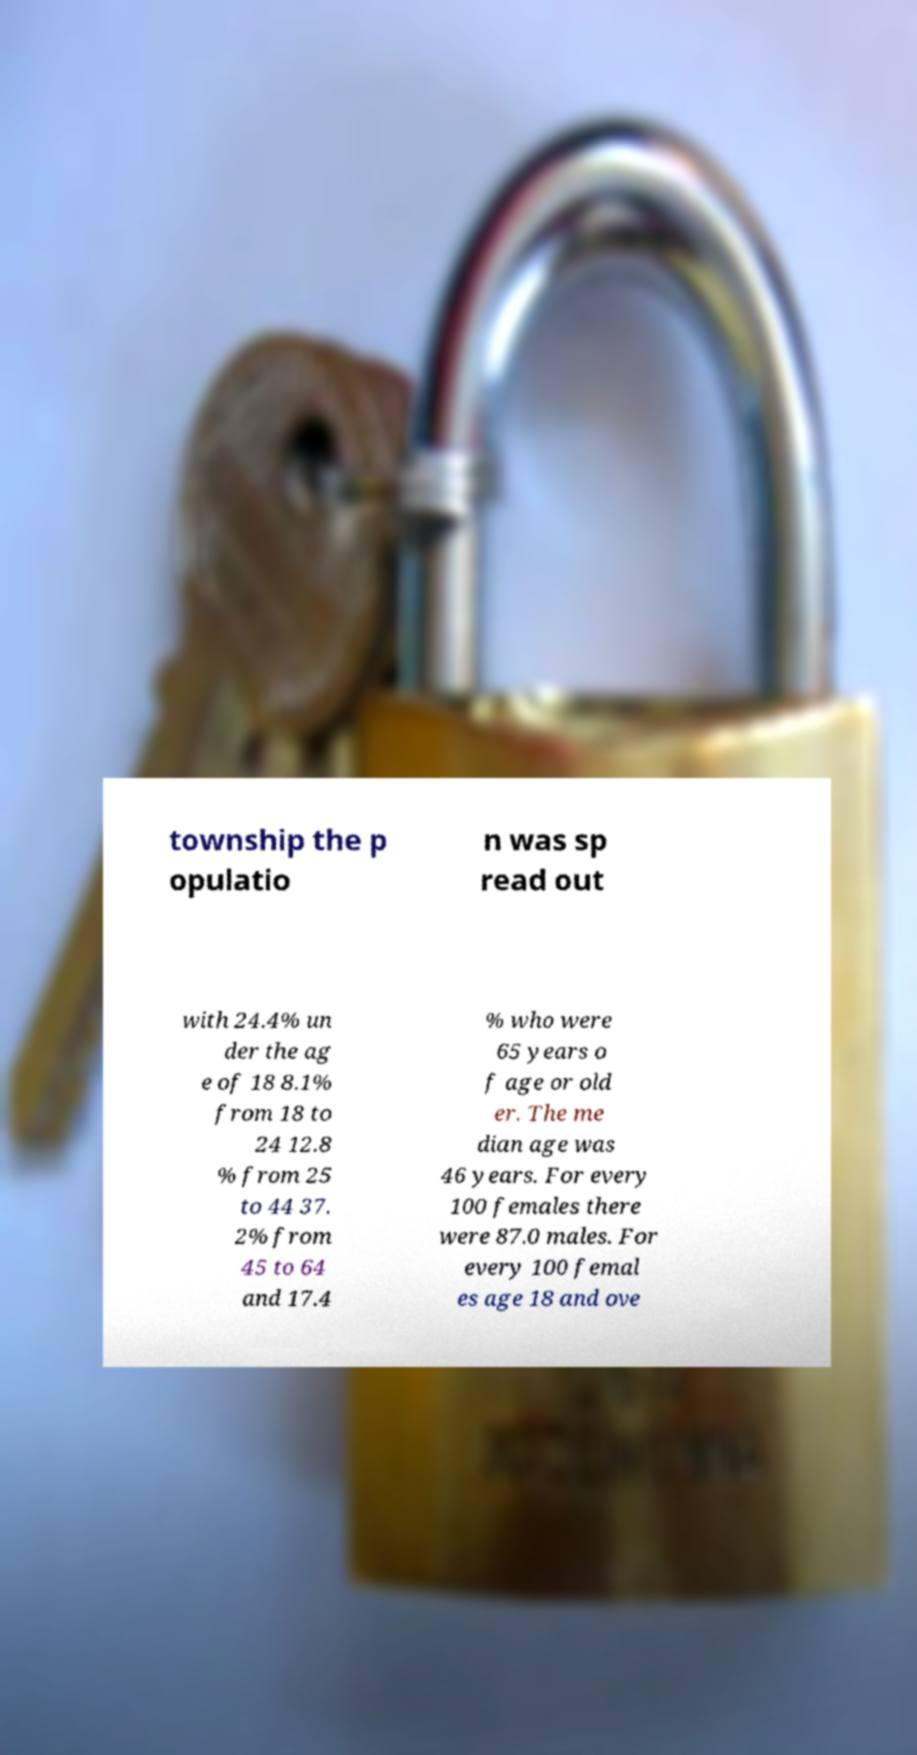Could you extract and type out the text from this image? township the p opulatio n was sp read out with 24.4% un der the ag e of 18 8.1% from 18 to 24 12.8 % from 25 to 44 37. 2% from 45 to 64 and 17.4 % who were 65 years o f age or old er. The me dian age was 46 years. For every 100 females there were 87.0 males. For every 100 femal es age 18 and ove 